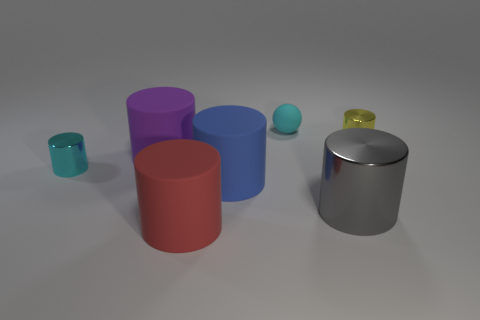Subtract all cyan cylinders. How many cylinders are left? 5 Subtract all yellow cylinders. How many cylinders are left? 5 Subtract all gray cylinders. Subtract all green balls. How many cylinders are left? 5 Add 2 balls. How many objects exist? 9 Subtract all cylinders. How many objects are left? 1 Subtract 0 green balls. How many objects are left? 7 Subtract all small blue matte cubes. Subtract all rubber objects. How many objects are left? 3 Add 4 yellow things. How many yellow things are left? 5 Add 6 big purple cylinders. How many big purple cylinders exist? 7 